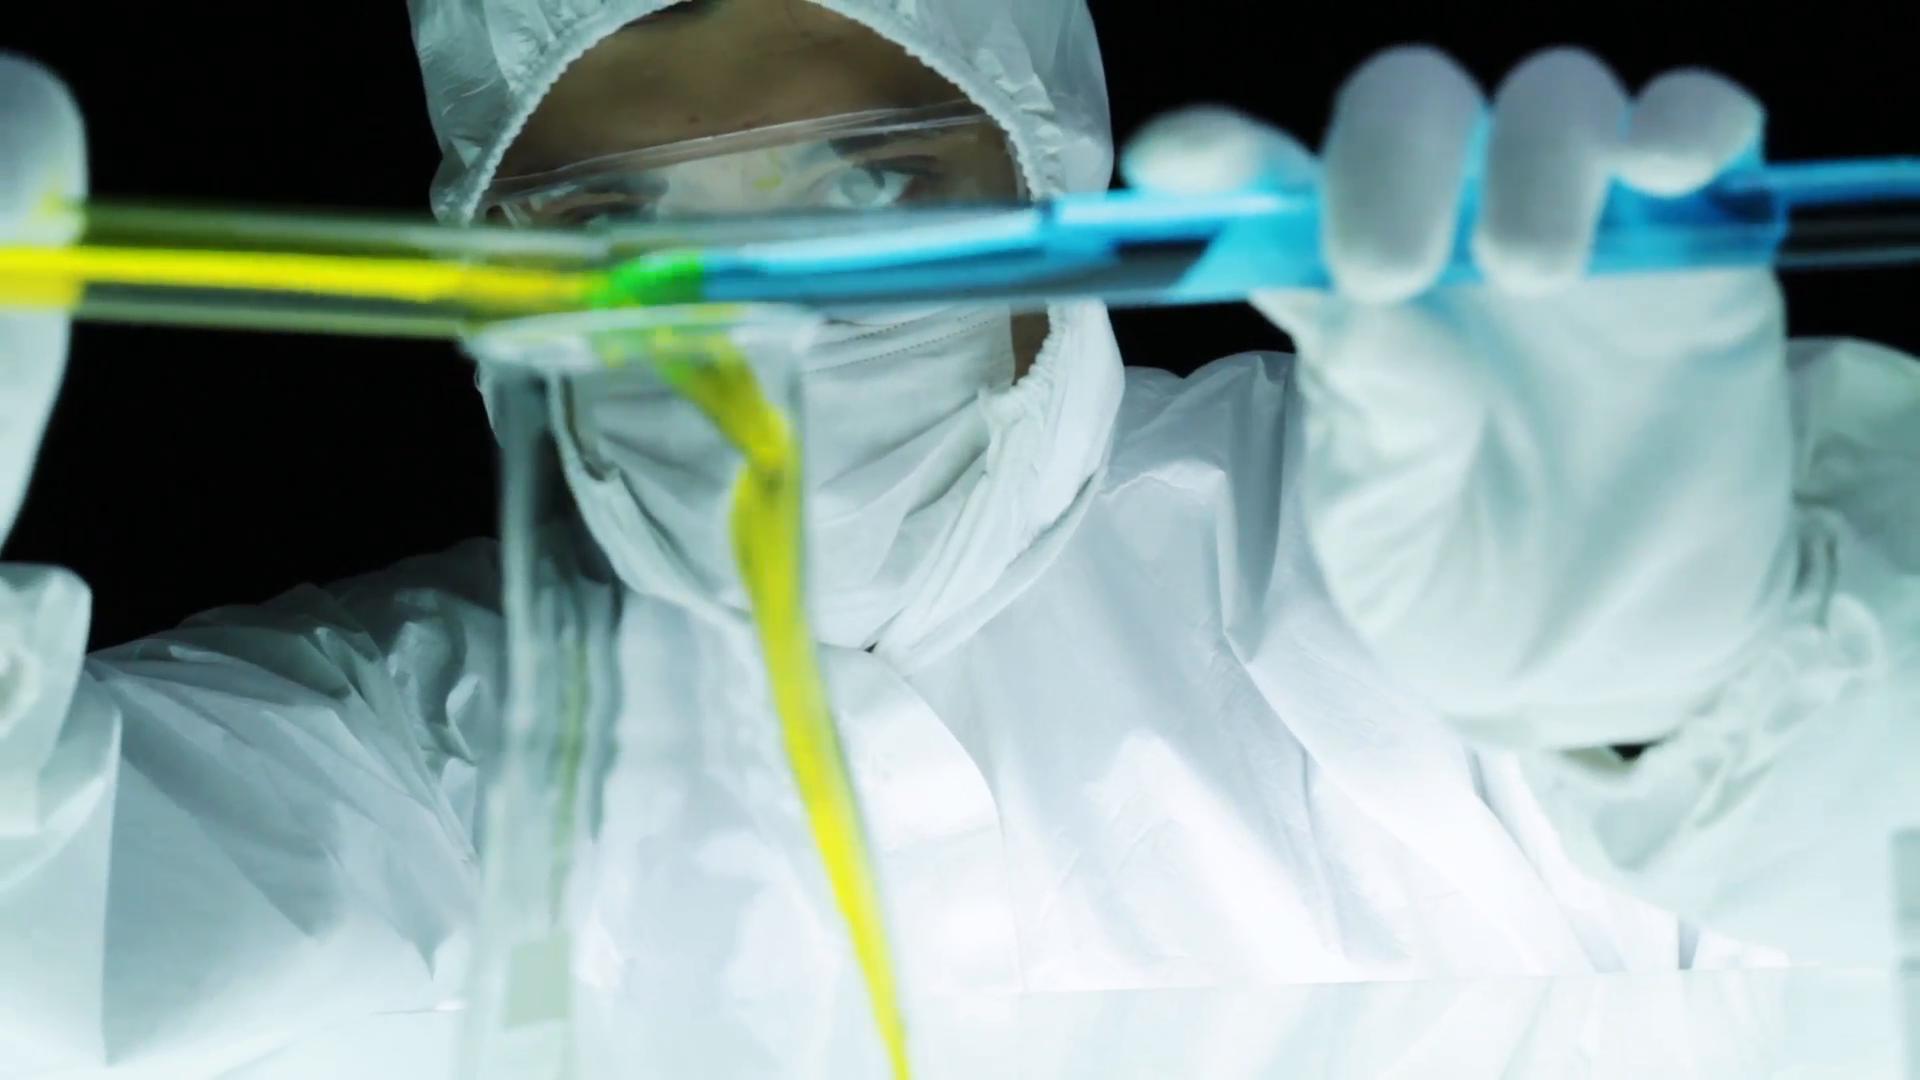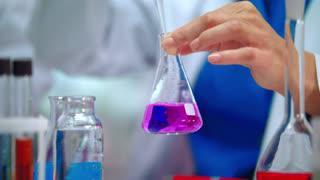The first image is the image on the left, the second image is the image on the right. Evaluate the accuracy of this statement regarding the images: "In at least one image, the container on the far right contains a reddish liquid.". Is it true? Answer yes or no. No. The first image is the image on the left, the second image is the image on the right. Evaluate the accuracy of this statement regarding the images: "There are more than five tubes filled with liquid in the image on the right.". Is it true? Answer yes or no. No. 